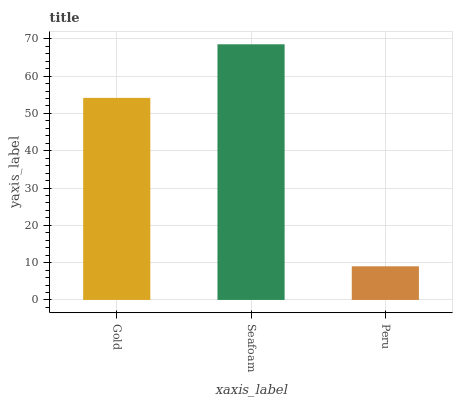Is Peru the minimum?
Answer yes or no. Yes. Is Seafoam the maximum?
Answer yes or no. Yes. Is Seafoam the minimum?
Answer yes or no. No. Is Peru the maximum?
Answer yes or no. No. Is Seafoam greater than Peru?
Answer yes or no. Yes. Is Peru less than Seafoam?
Answer yes or no. Yes. Is Peru greater than Seafoam?
Answer yes or no. No. Is Seafoam less than Peru?
Answer yes or no. No. Is Gold the high median?
Answer yes or no. Yes. Is Gold the low median?
Answer yes or no. Yes. Is Seafoam the high median?
Answer yes or no. No. Is Seafoam the low median?
Answer yes or no. No. 